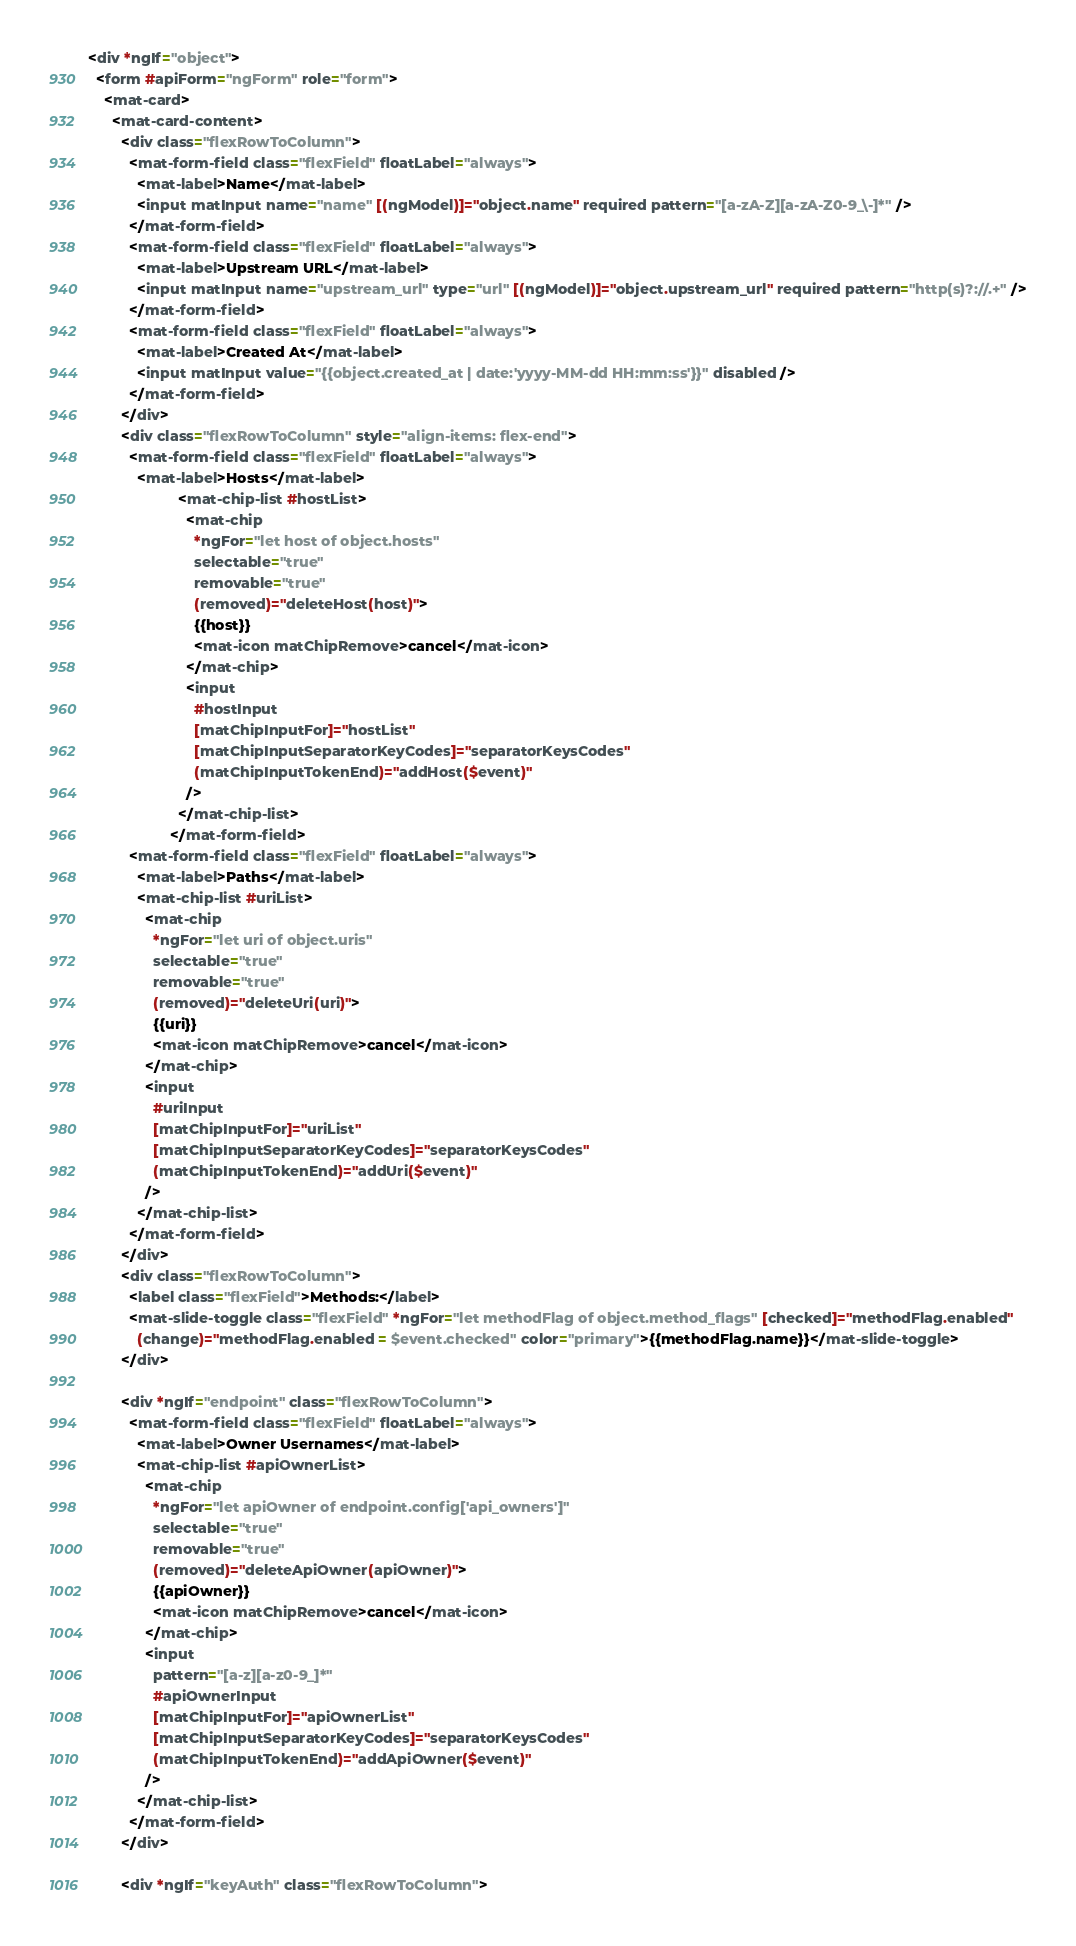Convert code to text. <code><loc_0><loc_0><loc_500><loc_500><_HTML_><div *ngIf="object">
  <form #apiForm="ngForm" role="form">
    <mat-card>
      <mat-card-content>
        <div class="flexRowToColumn">
          <mat-form-field class="flexField" floatLabel="always">
            <mat-label>Name</mat-label>
            <input matInput name="name" [(ngModel)]="object.name" required pattern="[a-zA-Z][a-zA-Z0-9_\-]*" />
          </mat-form-field>
          <mat-form-field class="flexField" floatLabel="always">
            <mat-label>Upstream URL</mat-label>
            <input matInput name="upstream_url" type="url" [(ngModel)]="object.upstream_url" required pattern="http(s)?://.+" />
          </mat-form-field>
          <mat-form-field class="flexField" floatLabel="always">
            <mat-label>Created At</mat-label>
            <input matInput value="{{object.created_at | date:'yyyy-MM-dd HH:mm:ss'}}" disabled />
          </mat-form-field>
        </div>
        <div class="flexRowToColumn" style="align-items: flex-end">
          <mat-form-field class="flexField" floatLabel="always">
            <mat-label>Hosts</mat-label>
					  <mat-chip-list #hostList>
					    <mat-chip
					      *ngFor="let host of object.hosts"
					      selectable="true"
					      removable="true"
					      (removed)="deleteHost(host)">
					      {{host}}
					      <mat-icon matChipRemove>cancel</mat-icon>
					    </mat-chip>
					    <input
					      #hostInput
					      [matChipInputFor]="hostList"
					      [matChipInputSeparatorKeyCodes]="separatorKeysCodes"
					      (matChipInputTokenEnd)="addHost($event)"
					    />
					  </mat-chip-list>
					</mat-form-field>
          <mat-form-field class="flexField" floatLabel="always">
            <mat-label>Paths</mat-label>
            <mat-chip-list #uriList>
              <mat-chip
                *ngFor="let uri of object.uris"
                selectable="true"
                removable="true"
                (removed)="deleteUri(uri)">
                {{uri}}
                <mat-icon matChipRemove>cancel</mat-icon>
              </mat-chip>
              <input
                #uriInput
                [matChipInputFor]="uriList"
                [matChipInputSeparatorKeyCodes]="separatorKeysCodes"
                (matChipInputTokenEnd)="addUri($event)"
              />
            </mat-chip-list>
          </mat-form-field>
        </div>
        <div class="flexRowToColumn">
          <label class="flexField">Methods:</label>
          <mat-slide-toggle class="flexField" *ngFor="let methodFlag of object.method_flags" [checked]="methodFlag.enabled"
            (change)="methodFlag.enabled = $event.checked" color="primary">{{methodFlag.name}}</mat-slide-toggle>
        </div>

        <div *ngIf="endpoint" class="flexRowToColumn">
          <mat-form-field class="flexField" floatLabel="always">
            <mat-label>Owner Usernames</mat-label>
            <mat-chip-list #apiOwnerList>
              <mat-chip
                *ngFor="let apiOwner of endpoint.config['api_owners']"
                selectable="true"
                removable="true"
                (removed)="deleteApiOwner(apiOwner)">
                {{apiOwner}}
                <mat-icon matChipRemove>cancel</mat-icon>
              </mat-chip>
              <input
                pattern="[a-z][a-z0-9_]*"
                #apiOwnerInput
                [matChipInputFor]="apiOwnerList"
                [matChipInputSeparatorKeyCodes]="separatorKeysCodes"
                (matChipInputTokenEnd)="addApiOwner($event)"
              />
            </mat-chip-list>
          </mat-form-field>
        </div>

        <div *ngIf="keyAuth" class="flexRowToColumn"></code> 